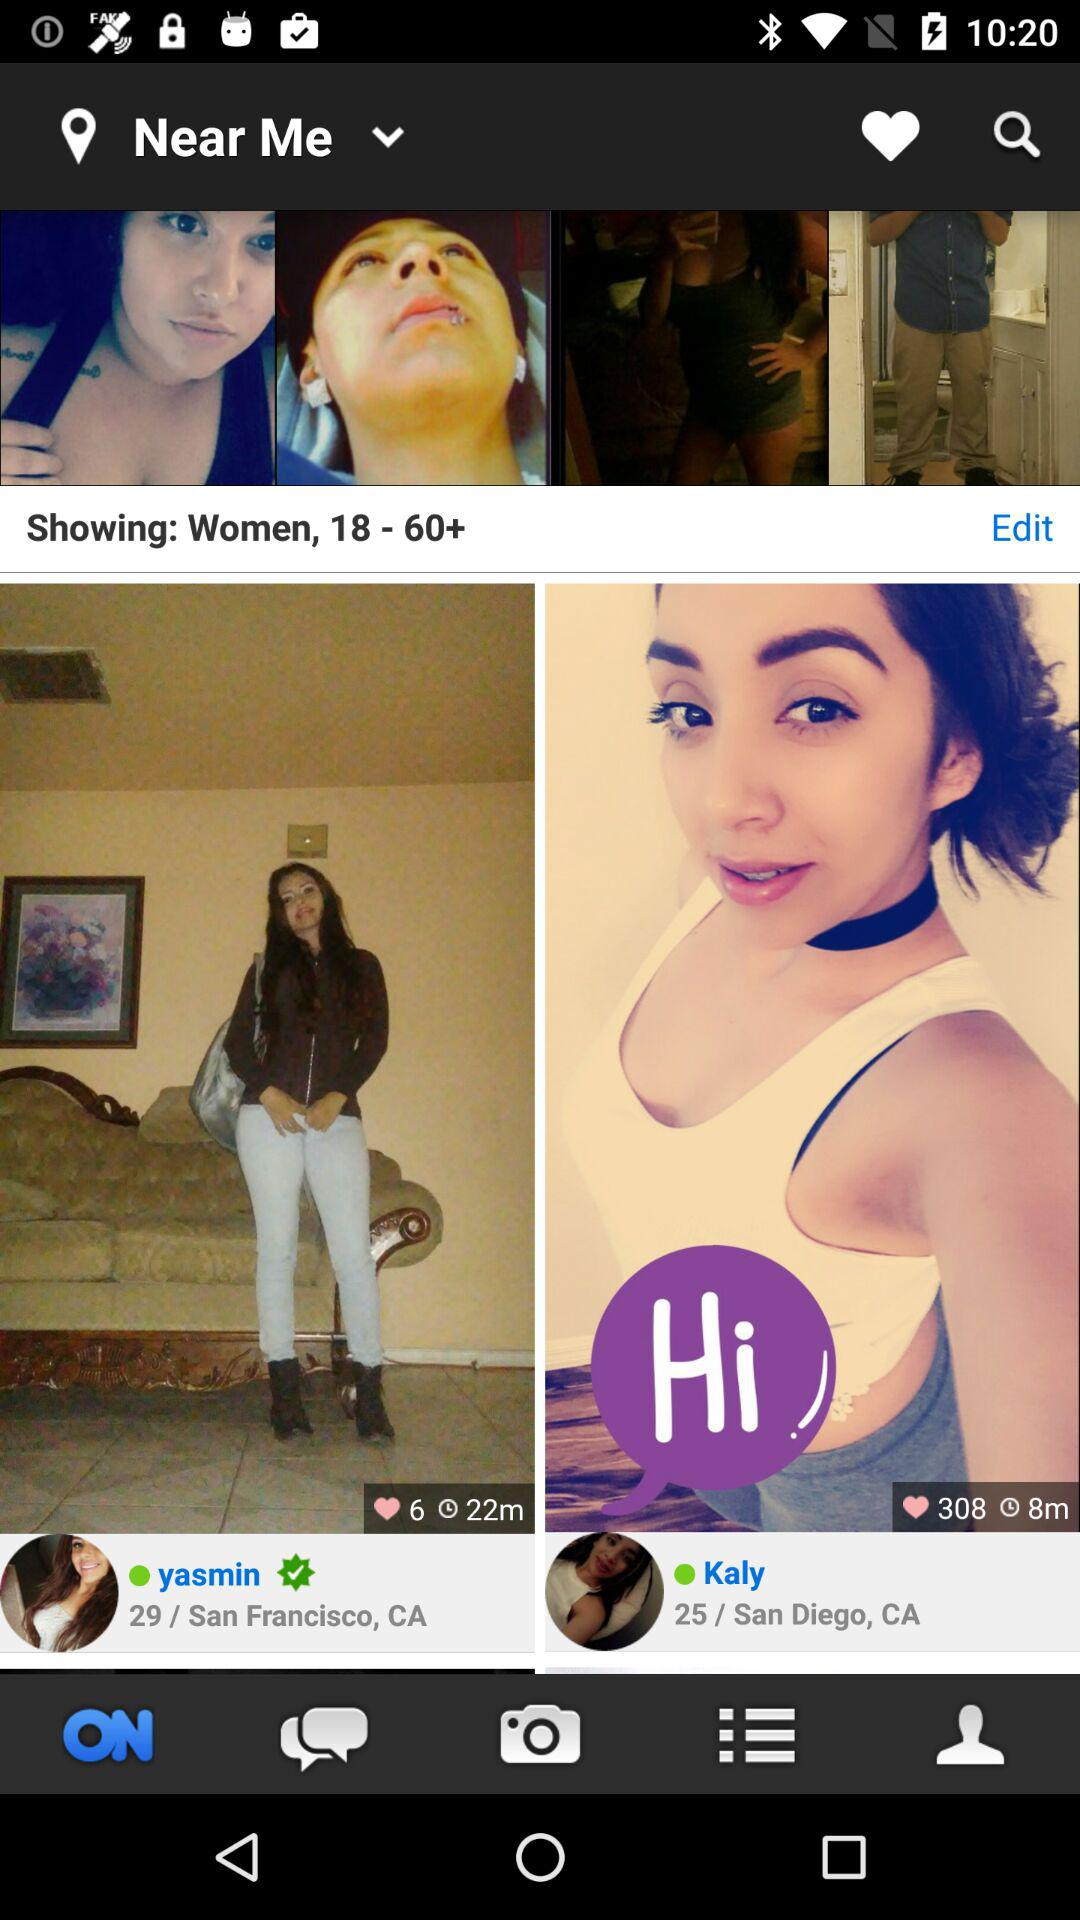What is the location of Yasmin? The location is San Francisco, CA. 